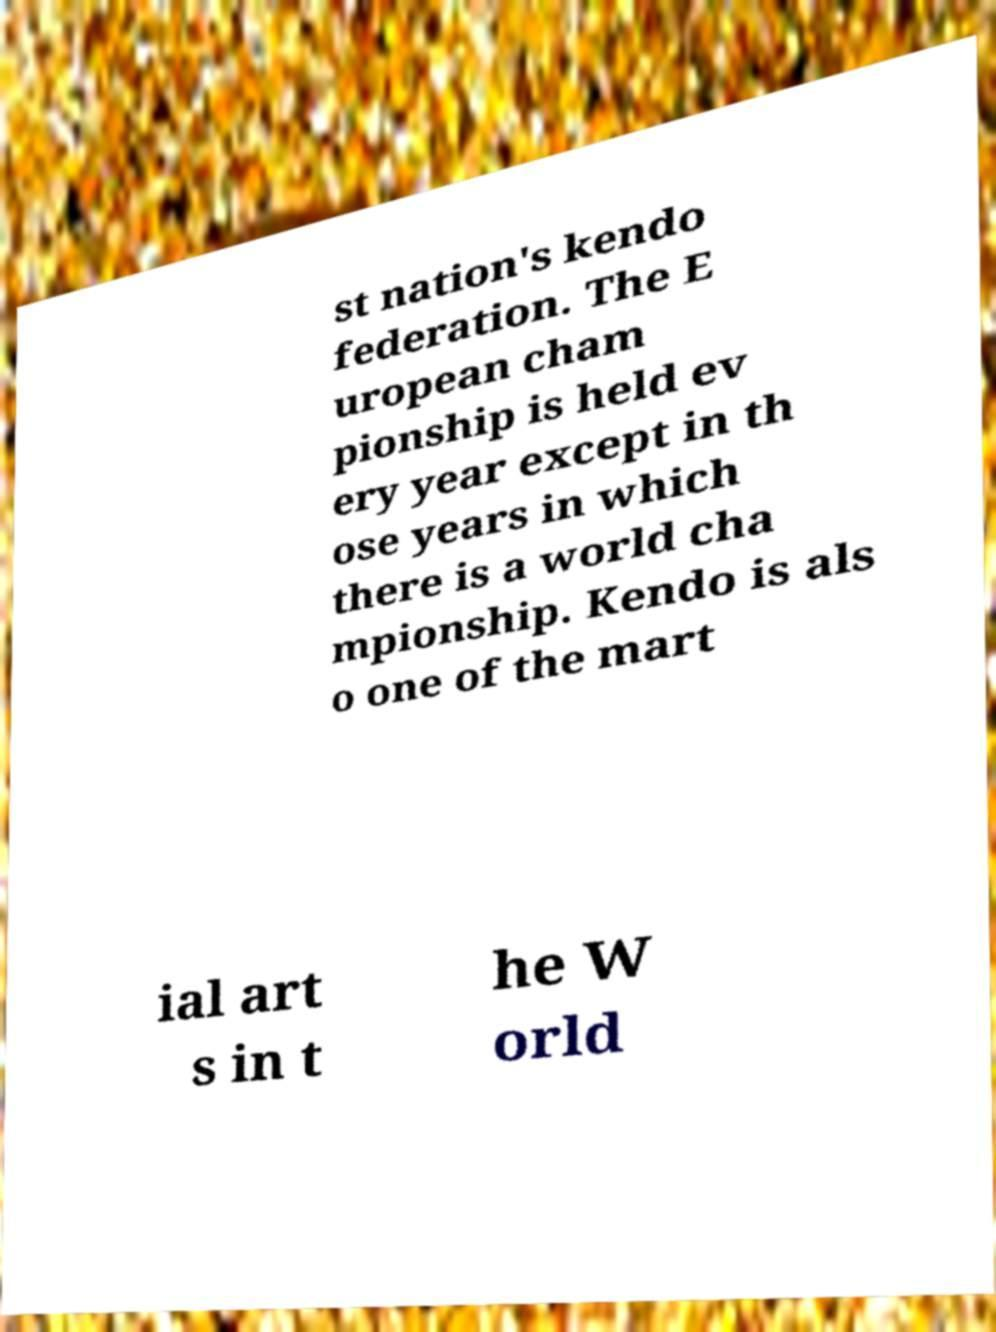I need the written content from this picture converted into text. Can you do that? st nation's kendo federation. The E uropean cham pionship is held ev ery year except in th ose years in which there is a world cha mpionship. Kendo is als o one of the mart ial art s in t he W orld 